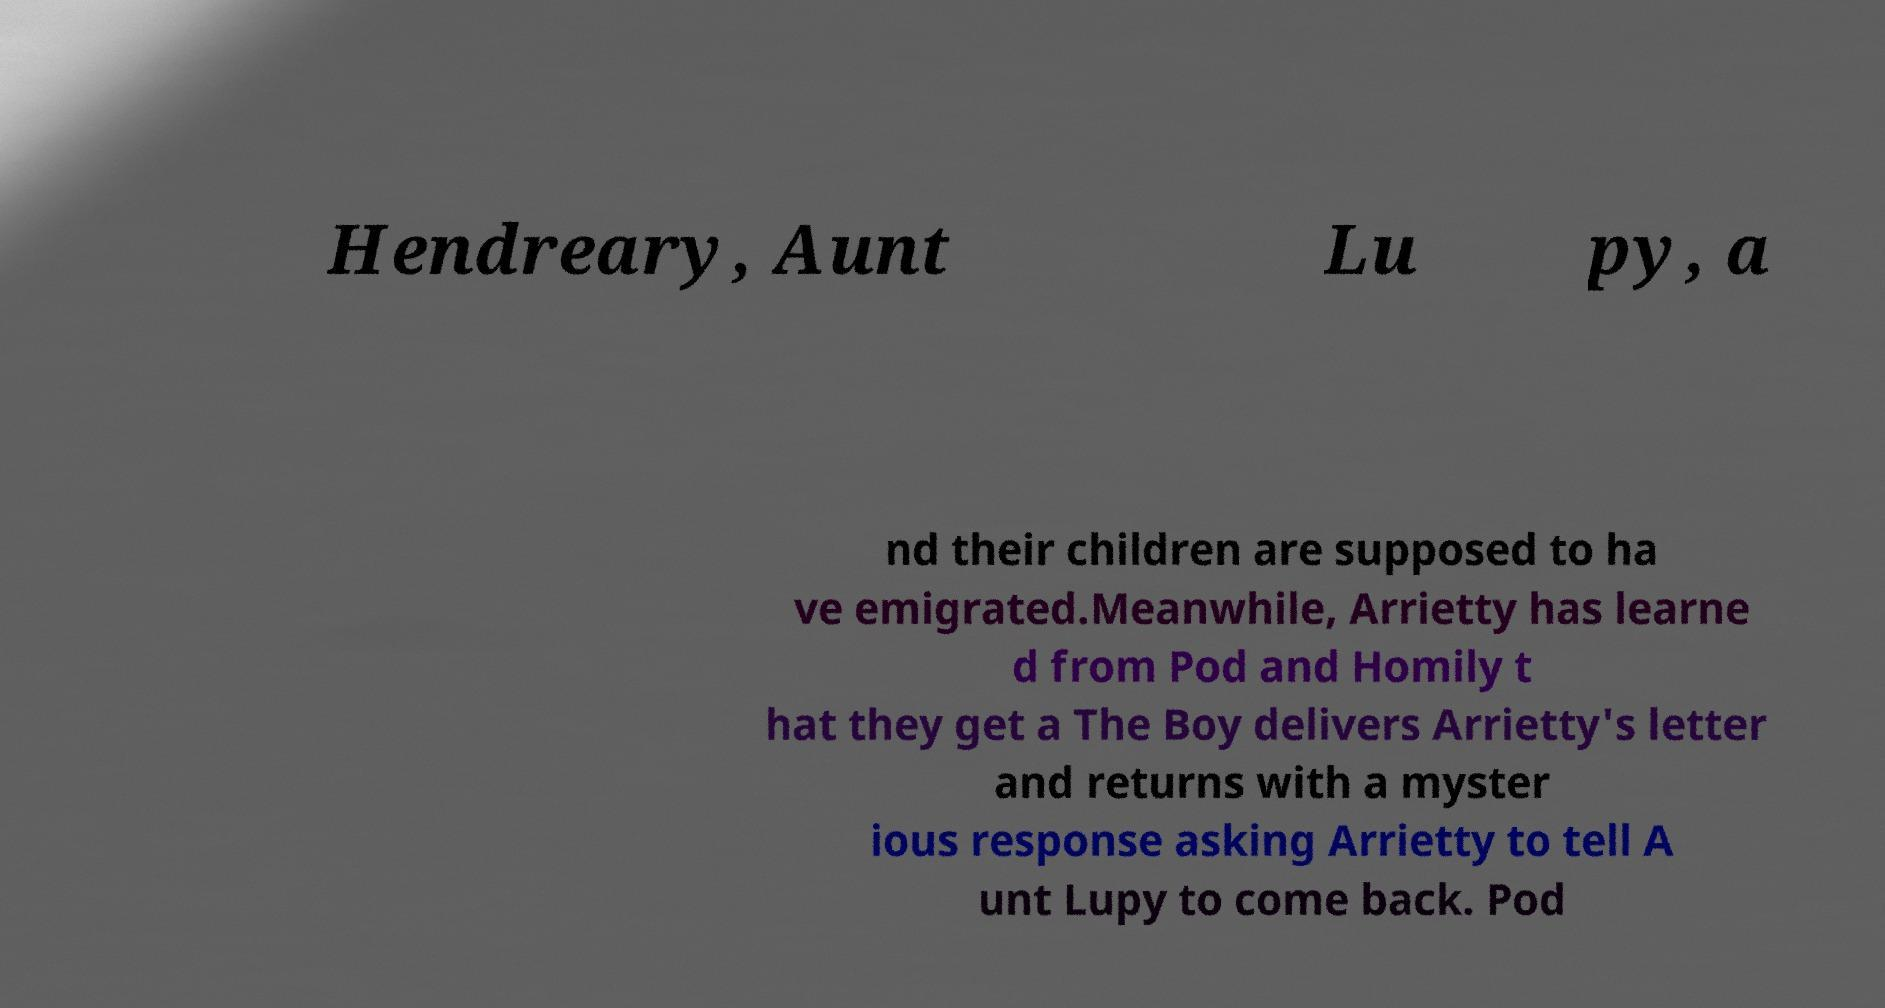What messages or text are displayed in this image? I need them in a readable, typed format. Hendreary, Aunt Lu py, a nd their children are supposed to ha ve emigrated.Meanwhile, Arrietty has learne d from Pod and Homily t hat they get a The Boy delivers Arrietty's letter and returns with a myster ious response asking Arrietty to tell A unt Lupy to come back. Pod 